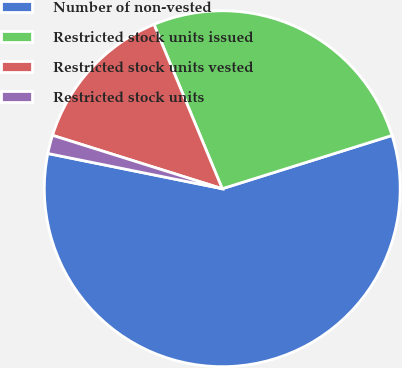<chart> <loc_0><loc_0><loc_500><loc_500><pie_chart><fcel>Number of non-vested<fcel>Restricted stock units issued<fcel>Restricted stock units vested<fcel>Restricted stock units<nl><fcel>58.01%<fcel>26.43%<fcel>13.88%<fcel>1.68%<nl></chart> 